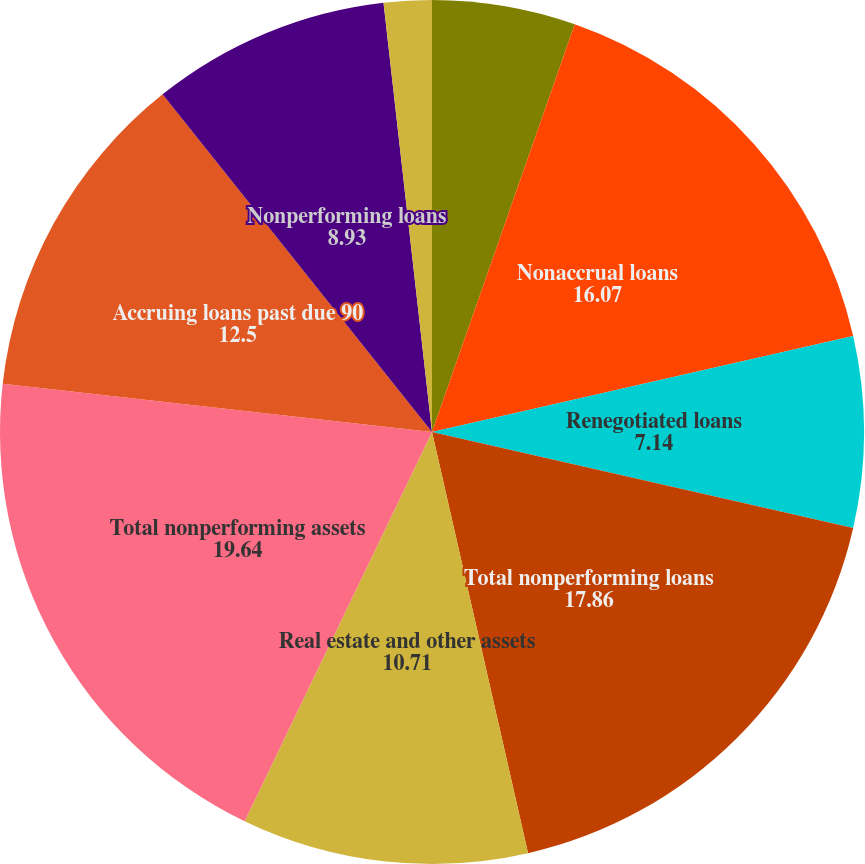Convert chart. <chart><loc_0><loc_0><loc_500><loc_500><pie_chart><fcel>December 31<fcel>Nonaccrual loans<fcel>Renegotiated loans<fcel>Total nonperforming loans<fcel>Real estate and other assets<fcel>Total nonperforming assets<fcel>Accruing loans past due 90<fcel>Nonperforming loans<fcel>Nonperforming loans to total<nl><fcel>5.36%<fcel>16.07%<fcel>7.14%<fcel>17.86%<fcel>10.71%<fcel>19.64%<fcel>12.5%<fcel>8.93%<fcel>1.79%<nl></chart> 